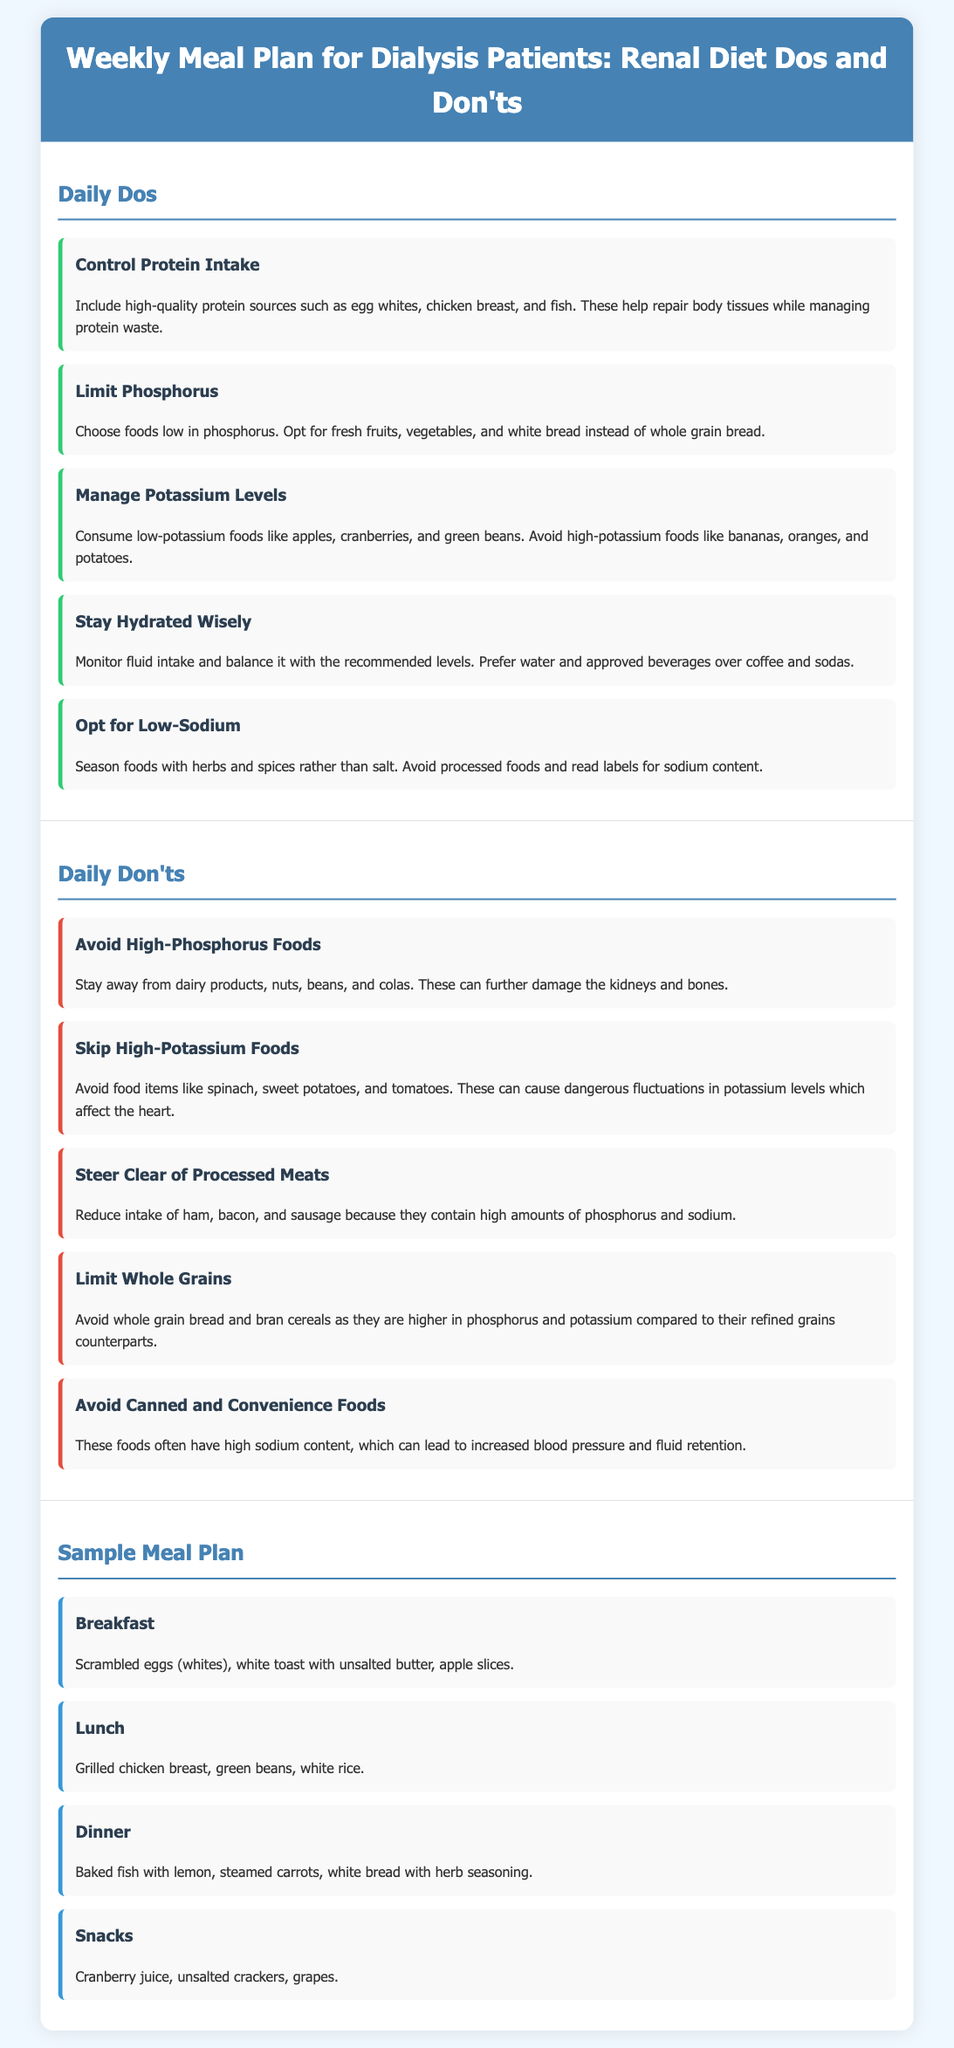What is one of the daily dos for dialysis patients? The daily dos include various recommendations for managing health, one of which is controlling protein intake.
Answer: Control Protein Intake Name a high-potassium food to avoid. The document lists several high-potassium foods that dialysis patients should avoid, including bananas.
Answer: Bananas What beverage is preferred over coffee and sodas? In managing hydration, the recommendation specifies a preference towards water and approved beverages, which is a key aspect of the dietary guidelines.
Answer: Water How many daily don'ts are listed in the document? There are five recommendations listed under the daily don'ts that patients should avoid to maintain better health while on dialysis.
Answer: Five What food is recommended for breakfast in the sample meal plan? The breakfast suggestion in the sample meal plan includes scrambled eggs (whites), which is a key part of a renal diet.
Answer: Scrambled eggs (whites) What is a food to avoid due to its high sodium content? The document highlights that patients should steer clear of canned and convenience foods, which are often high in sodium.
Answer: Canned foods Identify a low-sodium seasoning alternative mentioned. To maintain low sodium levels, the guideline recommends seasoning foods with herbs and spices as an alternative to salt.
Answer: Herbs and spices What is the focus of the weekly meal plan presented? The document centers around dietary recommendations specifically for dialysis patients and includes dos and don'ts alongside a sample meal plan.
Answer: Renal diet 